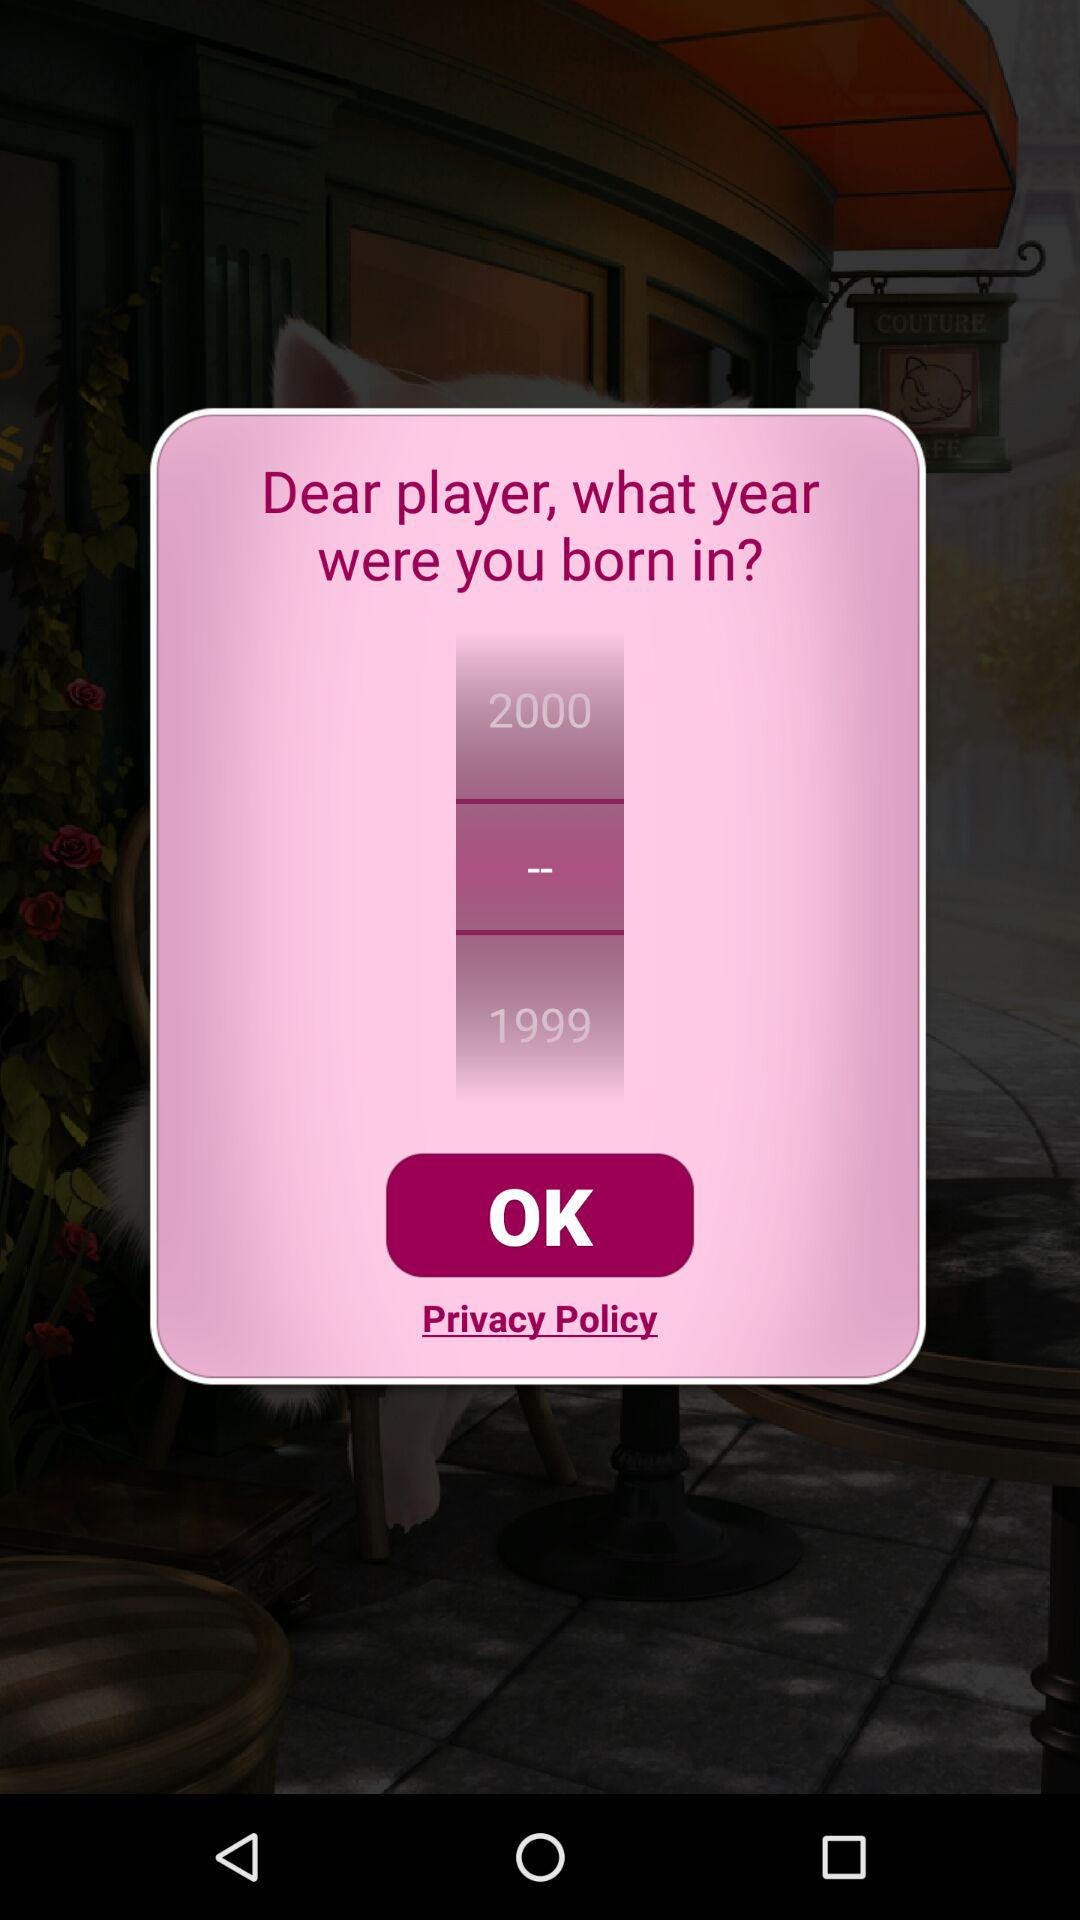Which year is the lower number?
Answer the question using a single word or phrase. 1999 